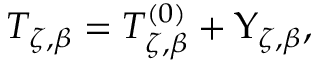<formula> <loc_0><loc_0><loc_500><loc_500>T _ { \zeta , \beta } = T _ { \zeta , \beta } ^ { \left ( 0 \right ) } + \Upsilon _ { \zeta , \beta } ,</formula> 